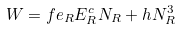<formula> <loc_0><loc_0><loc_500><loc_500>W = f e _ { R } E _ { R } ^ { c } N _ { R } + h N _ { R } ^ { 3 }</formula> 